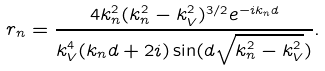Convert formula to latex. <formula><loc_0><loc_0><loc_500><loc_500>r _ { n } = \frac { 4 k _ { n } ^ { 2 } ( k _ { n } ^ { 2 } - k _ { V } ^ { 2 } ) ^ { 3 / 2 } e ^ { - i k _ { n } d } } { k _ { V } ^ { 4 } ( k _ { n } d + 2 i ) \sin ( d \sqrt { k _ { n } ^ { 2 } - k _ { V } ^ { 2 } } ) } .</formula> 